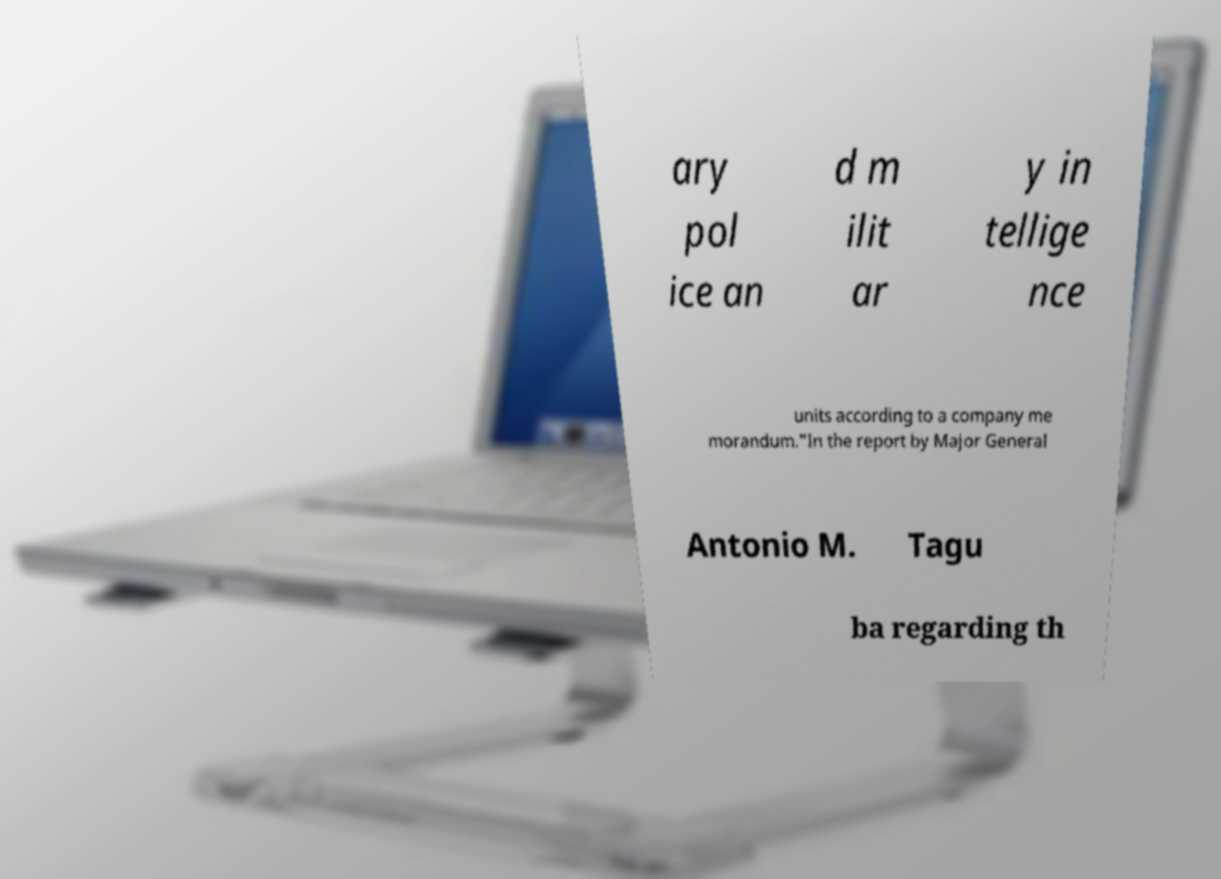I need the written content from this picture converted into text. Can you do that? ary pol ice an d m ilit ar y in tellige nce units according to a company me morandum."In the report by Major General Antonio M. Tagu ba regarding th 